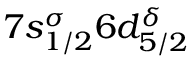<formula> <loc_0><loc_0><loc_500><loc_500>7 s _ { 1 / 2 } ^ { \sigma } 6 d _ { 5 / 2 } ^ { \delta }</formula> 